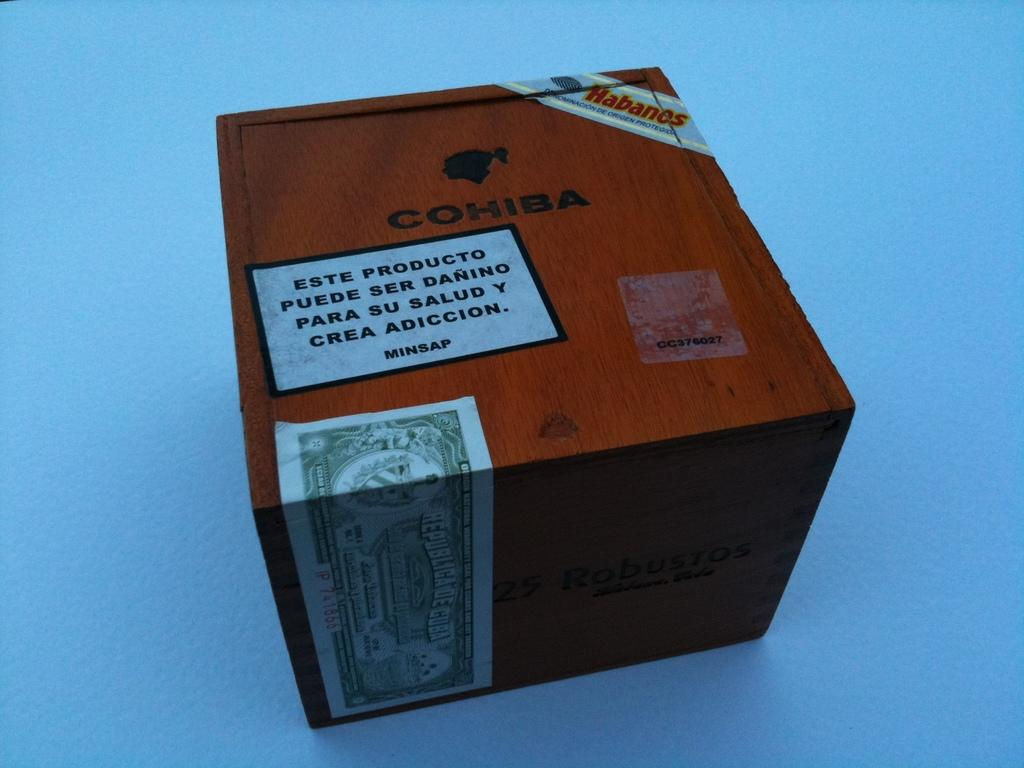<image>
Summarize the visual content of the image. A wooden box is inscribed with the word Cohiba. 